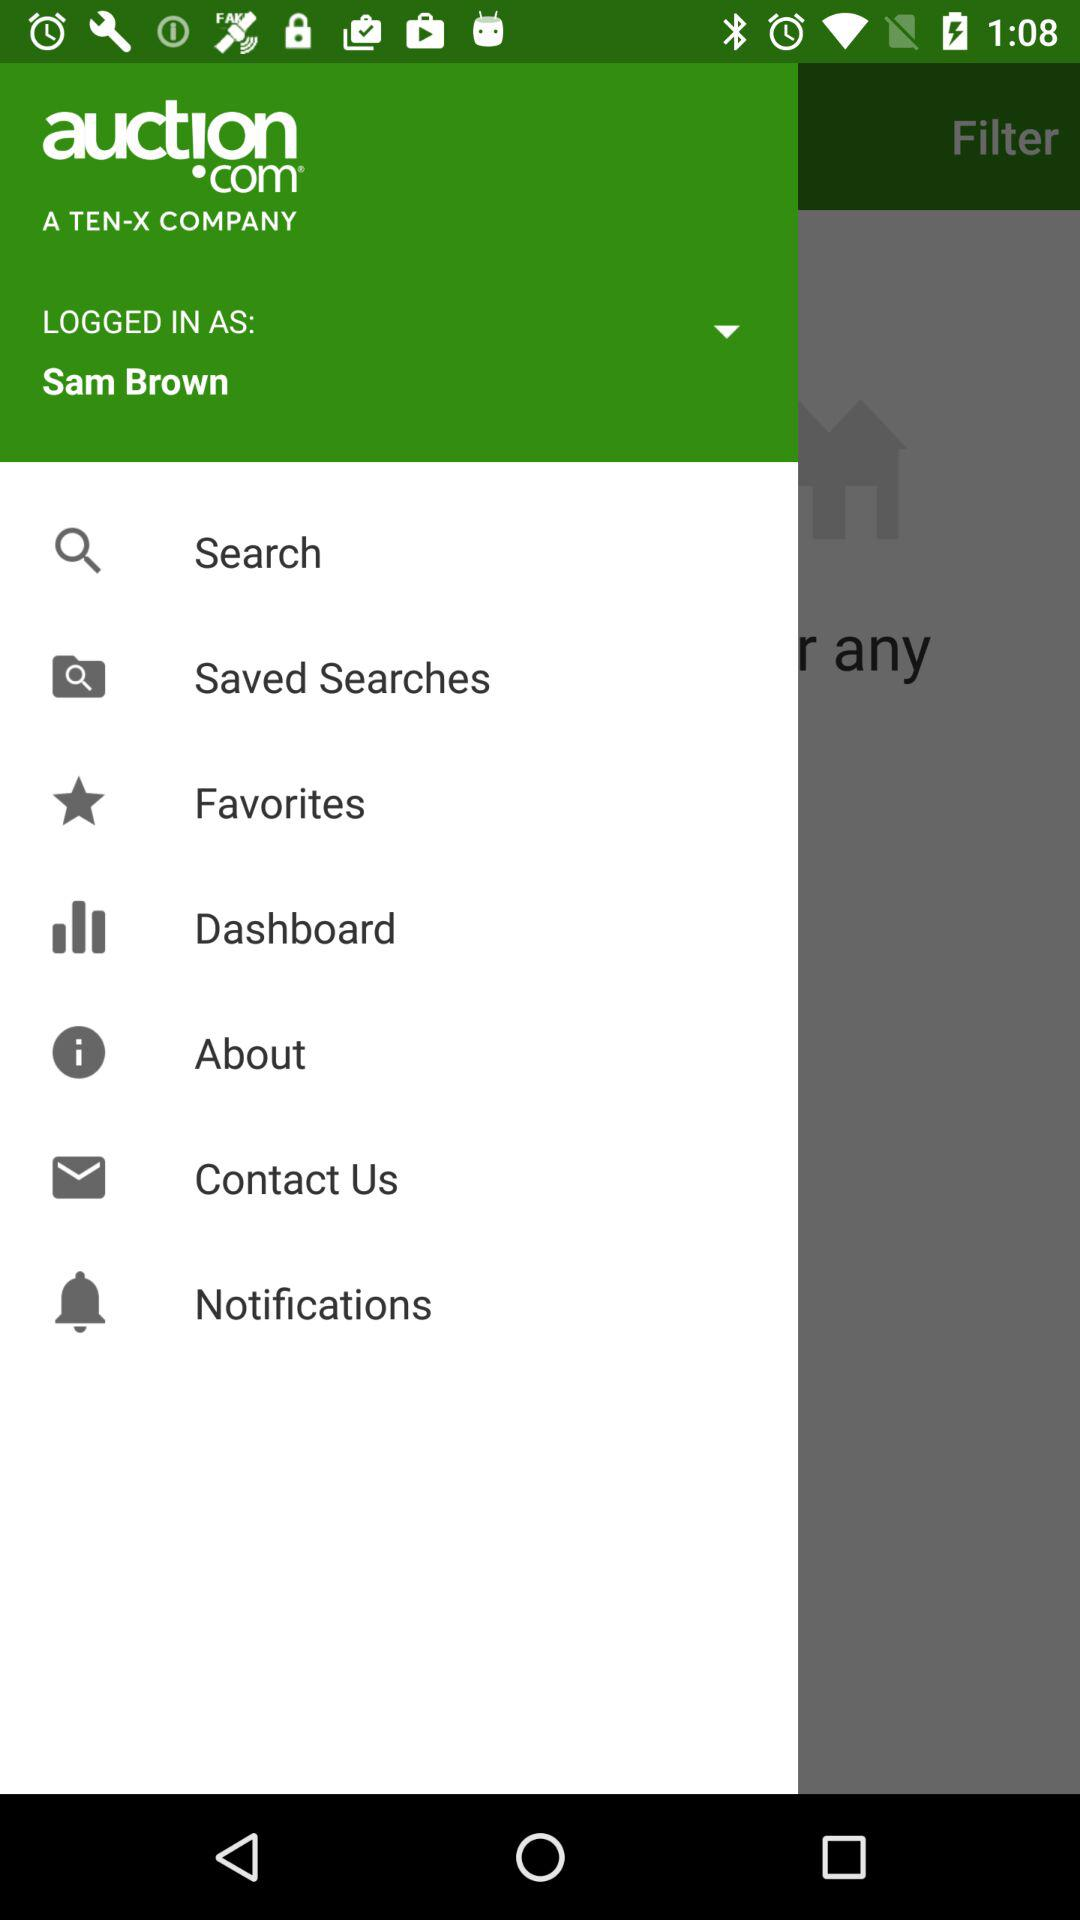What is the app name? The app name is "auction.com". 